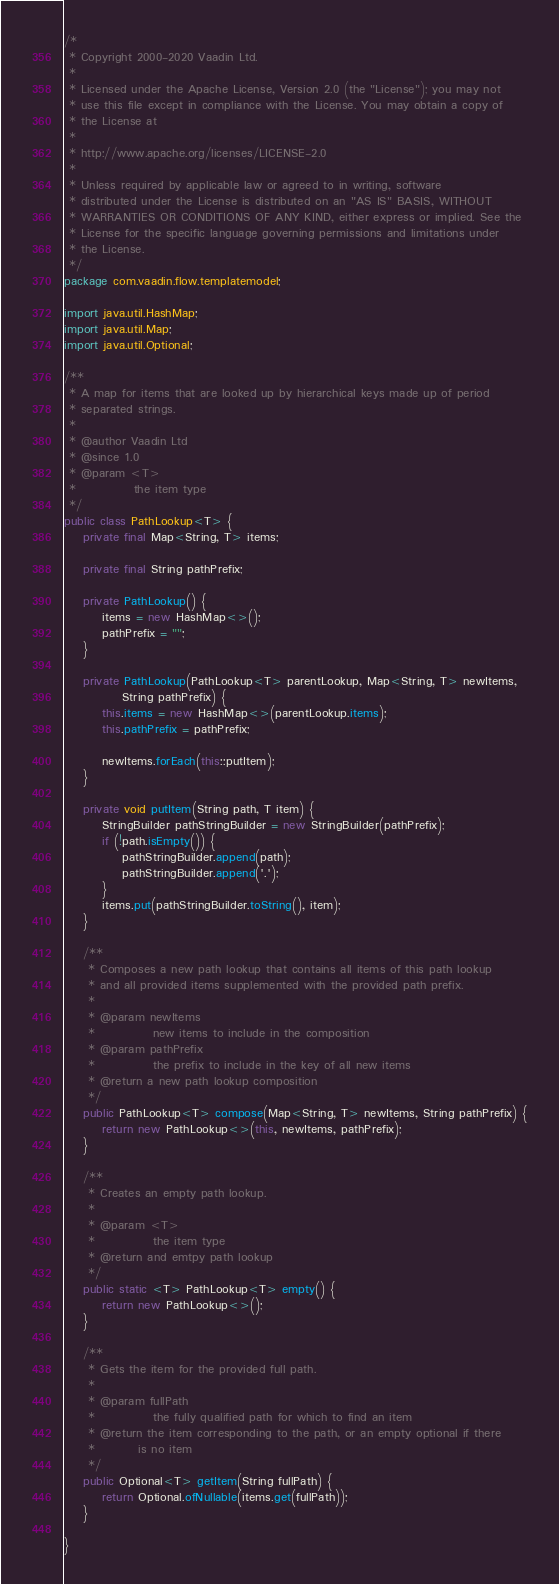Convert code to text. <code><loc_0><loc_0><loc_500><loc_500><_Java_>/*
 * Copyright 2000-2020 Vaadin Ltd.
 *
 * Licensed under the Apache License, Version 2.0 (the "License"); you may not
 * use this file except in compliance with the License. You may obtain a copy of
 * the License at
 *
 * http://www.apache.org/licenses/LICENSE-2.0
 *
 * Unless required by applicable law or agreed to in writing, software
 * distributed under the License is distributed on an "AS IS" BASIS, WITHOUT
 * WARRANTIES OR CONDITIONS OF ANY KIND, either express or implied. See the
 * License for the specific language governing permissions and limitations under
 * the License.
 */
package com.vaadin.flow.templatemodel;

import java.util.HashMap;
import java.util.Map;
import java.util.Optional;

/**
 * A map for items that are looked up by hierarchical keys made up of period
 * separated strings.
 *
 * @author Vaadin Ltd
 * @since 1.0
 * @param <T>
 *            the item type
 */
public class PathLookup<T> {
    private final Map<String, T> items;

    private final String pathPrefix;

    private PathLookup() {
        items = new HashMap<>();
        pathPrefix = "";
    }

    private PathLookup(PathLookup<T> parentLookup, Map<String, T> newItems,
            String pathPrefix) {
        this.items = new HashMap<>(parentLookup.items);
        this.pathPrefix = pathPrefix;

        newItems.forEach(this::putItem);
    }

    private void putItem(String path, T item) {
        StringBuilder pathStringBuilder = new StringBuilder(pathPrefix);
        if (!path.isEmpty()) {
            pathStringBuilder.append(path);
            pathStringBuilder.append('.');
        }
        items.put(pathStringBuilder.toString(), item);
    }

    /**
     * Composes a new path lookup that contains all items of this path lookup
     * and all provided items supplemented with the provided path prefix.
     *
     * @param newItems
     *            new items to include in the composition
     * @param pathPrefix
     *            the prefix to include in the key of all new items
     * @return a new path lookup composition
     */
    public PathLookup<T> compose(Map<String, T> newItems, String pathPrefix) {
        return new PathLookup<>(this, newItems, pathPrefix);
    }

    /**
     * Creates an empty path lookup.
     *
     * @param <T>
     *            the item type
     * @return and emtpy path lookup
     */
    public static <T> PathLookup<T> empty() {
        return new PathLookup<>();
    }

    /**
     * Gets the item for the provided full path.
     * 
     * @param fullPath
     *            the fully qualified path for which to find an item
     * @return the item corresponding to the path, or an empty optional if there
     *         is no item
     */
    public Optional<T> getItem(String fullPath) {
        return Optional.ofNullable(items.get(fullPath));
    }

}
</code> 